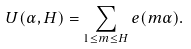Convert formula to latex. <formula><loc_0><loc_0><loc_500><loc_500>U ( \alpha , H ) = \sum _ { 1 \leq m \leq H } e ( m \alpha ) .</formula> 